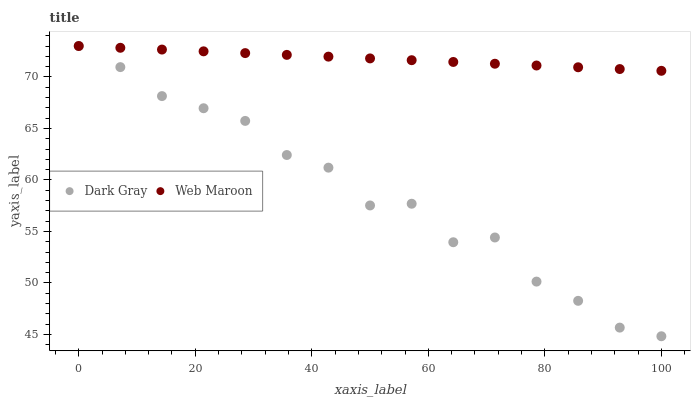Does Dark Gray have the minimum area under the curve?
Answer yes or no. Yes. Does Web Maroon have the maximum area under the curve?
Answer yes or no. Yes. Does Web Maroon have the minimum area under the curve?
Answer yes or no. No. Is Web Maroon the smoothest?
Answer yes or no. Yes. Is Dark Gray the roughest?
Answer yes or no. Yes. Is Web Maroon the roughest?
Answer yes or no. No. Does Dark Gray have the lowest value?
Answer yes or no. Yes. Does Web Maroon have the lowest value?
Answer yes or no. No. Does Web Maroon have the highest value?
Answer yes or no. Yes. Does Dark Gray intersect Web Maroon?
Answer yes or no. Yes. Is Dark Gray less than Web Maroon?
Answer yes or no. No. Is Dark Gray greater than Web Maroon?
Answer yes or no. No. 